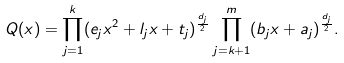Convert formula to latex. <formula><loc_0><loc_0><loc_500><loc_500>Q ( x ) = \prod _ { j = 1 } ^ { k } ( e _ { j } x ^ { 2 } + l _ { j } x + t _ { j } ) ^ { \frac { d _ { j } } { 2 } } \prod _ { j = k + 1 } ^ { m } ( b _ { j } x + a _ { j } ) ^ { \frac { d _ { j } } { 2 } } .</formula> 